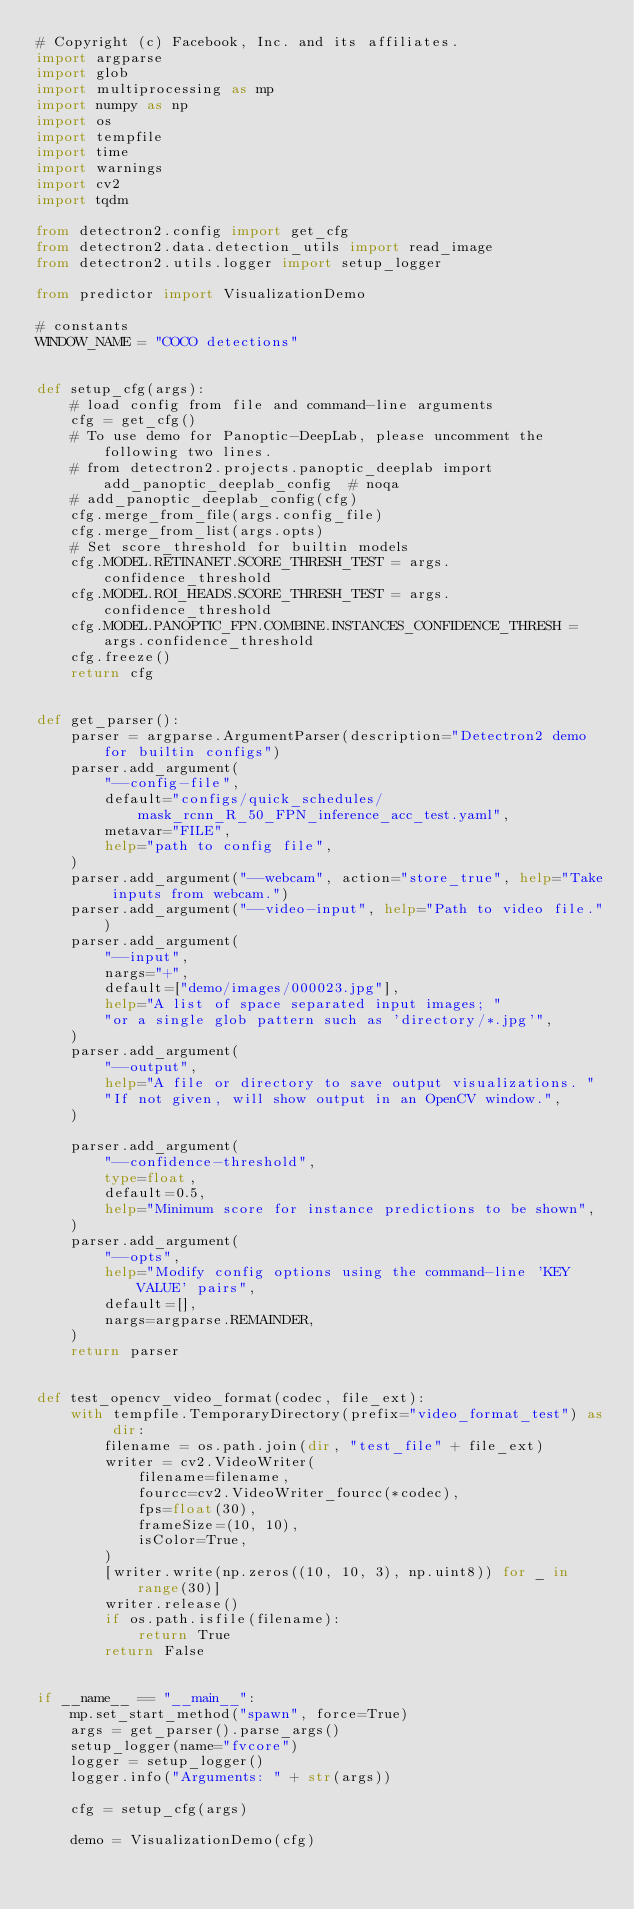Convert code to text. <code><loc_0><loc_0><loc_500><loc_500><_Python_># Copyright (c) Facebook, Inc. and its affiliates.
import argparse
import glob
import multiprocessing as mp
import numpy as np
import os
import tempfile
import time
import warnings
import cv2
import tqdm

from detectron2.config import get_cfg
from detectron2.data.detection_utils import read_image
from detectron2.utils.logger import setup_logger

from predictor import VisualizationDemo

# constants
WINDOW_NAME = "COCO detections"


def setup_cfg(args):
    # load config from file and command-line arguments
    cfg = get_cfg()
    # To use demo for Panoptic-DeepLab, please uncomment the following two lines.
    # from detectron2.projects.panoptic_deeplab import add_panoptic_deeplab_config  # noqa
    # add_panoptic_deeplab_config(cfg)
    cfg.merge_from_file(args.config_file)
    cfg.merge_from_list(args.opts)
    # Set score_threshold for builtin models
    cfg.MODEL.RETINANET.SCORE_THRESH_TEST = args.confidence_threshold
    cfg.MODEL.ROI_HEADS.SCORE_THRESH_TEST = args.confidence_threshold
    cfg.MODEL.PANOPTIC_FPN.COMBINE.INSTANCES_CONFIDENCE_THRESH = args.confidence_threshold
    cfg.freeze()
    return cfg


def get_parser():
    parser = argparse.ArgumentParser(description="Detectron2 demo for builtin configs")
    parser.add_argument(
        "--config-file",
        default="configs/quick_schedules/mask_rcnn_R_50_FPN_inference_acc_test.yaml",
        metavar="FILE",
        help="path to config file",
    )
    parser.add_argument("--webcam", action="store_true", help="Take inputs from webcam.")
    parser.add_argument("--video-input", help="Path to video file.")
    parser.add_argument(
        "--input",
        nargs="+",
        default=["demo/images/000023.jpg"],
        help="A list of space separated input images; "
        "or a single glob pattern such as 'directory/*.jpg'",
    )
    parser.add_argument(
        "--output",
        help="A file or directory to save output visualizations. "
        "If not given, will show output in an OpenCV window.",
    )

    parser.add_argument(
        "--confidence-threshold",
        type=float,
        default=0.5,
        help="Minimum score for instance predictions to be shown",
    )
    parser.add_argument(
        "--opts",
        help="Modify config options using the command-line 'KEY VALUE' pairs",
        default=[],
        nargs=argparse.REMAINDER,
    )
    return parser


def test_opencv_video_format(codec, file_ext):
    with tempfile.TemporaryDirectory(prefix="video_format_test") as dir:
        filename = os.path.join(dir, "test_file" + file_ext)
        writer = cv2.VideoWriter(
            filename=filename,
            fourcc=cv2.VideoWriter_fourcc(*codec),
            fps=float(30),
            frameSize=(10, 10),
            isColor=True,
        )
        [writer.write(np.zeros((10, 10, 3), np.uint8)) for _ in range(30)]
        writer.release()
        if os.path.isfile(filename):
            return True
        return False


if __name__ == "__main__":
    mp.set_start_method("spawn", force=True)
    args = get_parser().parse_args()
    setup_logger(name="fvcore")
    logger = setup_logger()
    logger.info("Arguments: " + str(args))

    cfg = setup_cfg(args)

    demo = VisualizationDemo(cfg)
</code> 